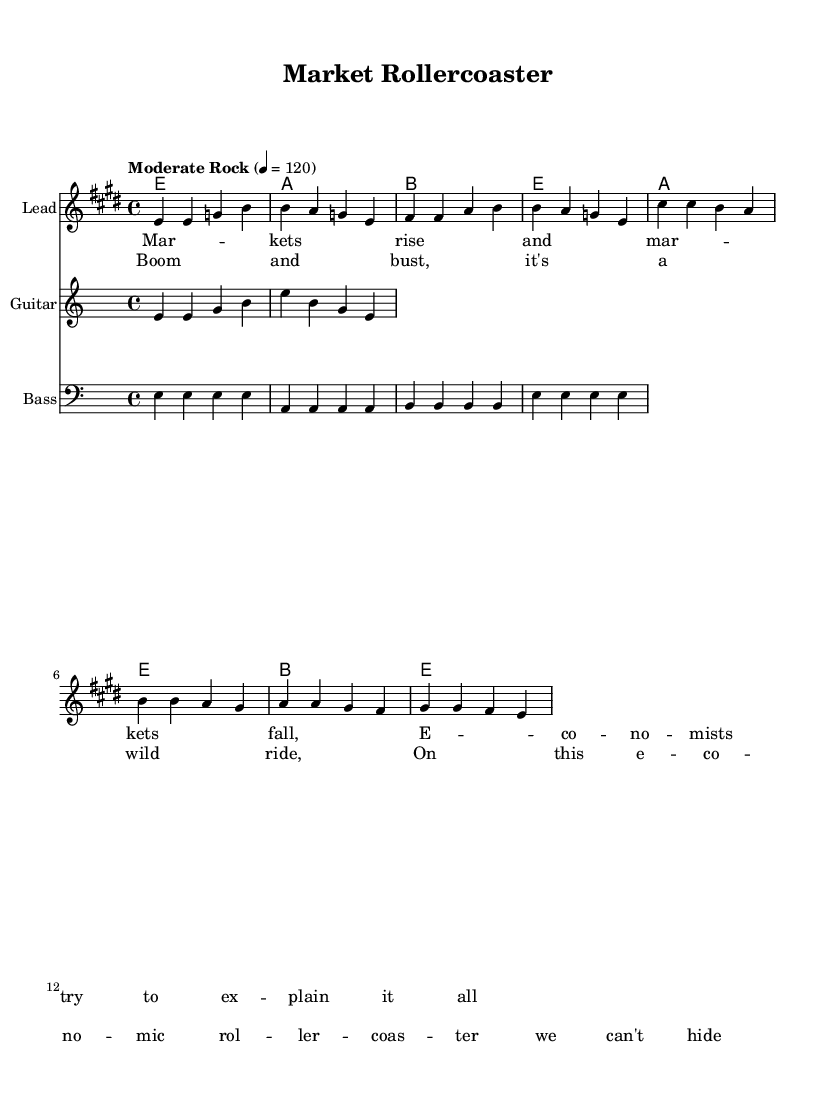What is the key signature of this music? The key signature is E major, which has four sharps (F#, C#, G#, D#). This can be determined by looking at the beginning of the score where the key signature is indicated.
Answer: E major What is the time signature of this music? The time signature is 4/4, which indicates four beats per measure and a quarter note gets one beat. This is found at the beginning of the score next to the key signature.
Answer: 4/4 What is the tempo marking for this piece? The tempo marking is "Moderate Rock," with a specific metronome marking of 120 beats per minute. This is written above the score in the tempo directive.
Answer: Moderate Rock How many measures are in the verse section? The verse section contains four measures. This can be counted by looking at the melody lines and noting where phrases begin and end.
Answer: Four What chord is played in the chorus's first measure? The chord played in the chorus's first measure is A major. This is determined by referencing the chord progression notated at the beginning of the score next to the respective melodies.
Answer: A In which part of the music do we find the lyrics about "Market Rollercoaster"? The lyrics about "Market Rollercoaster" are found in the verse section, specifically the lines that begin with "Markets rise and markets fall." This is indicated in the lyrics box under the melody in the score.
Answer: Verse What instrument is specified for the guitar section in this music? The instrument specified for the guitar section is "Guitar." This is stated at the beginning of the staff that corresponds to the guitar riff in the score.
Answer: Guitar 